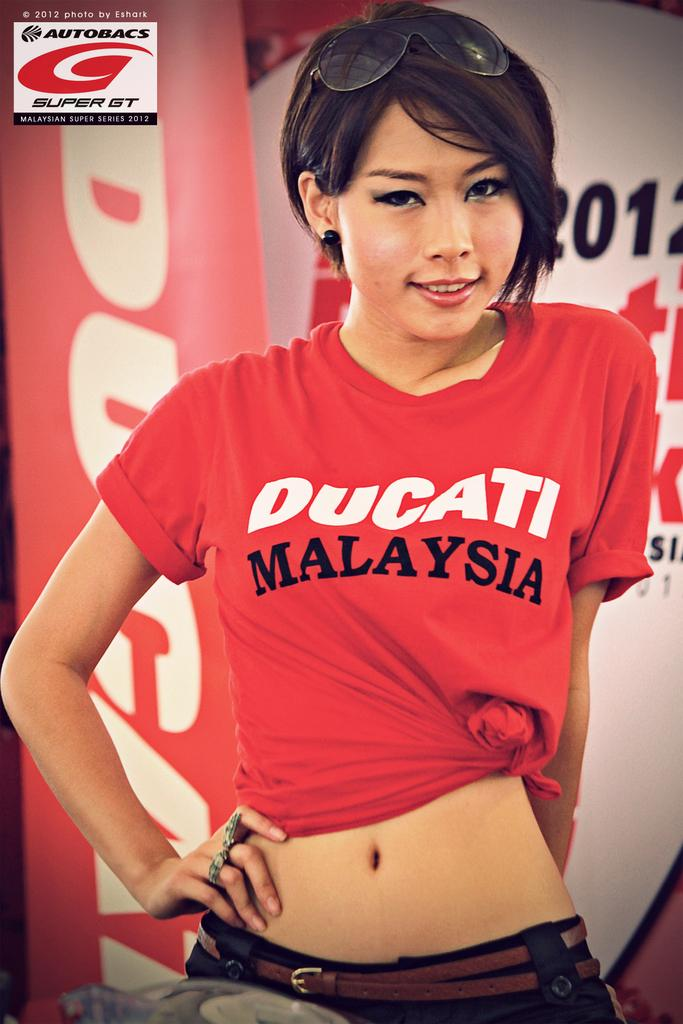<image>
Provide a brief description of the given image. A woman is wearing a red t-shirt that says Malaysia in black text on it 